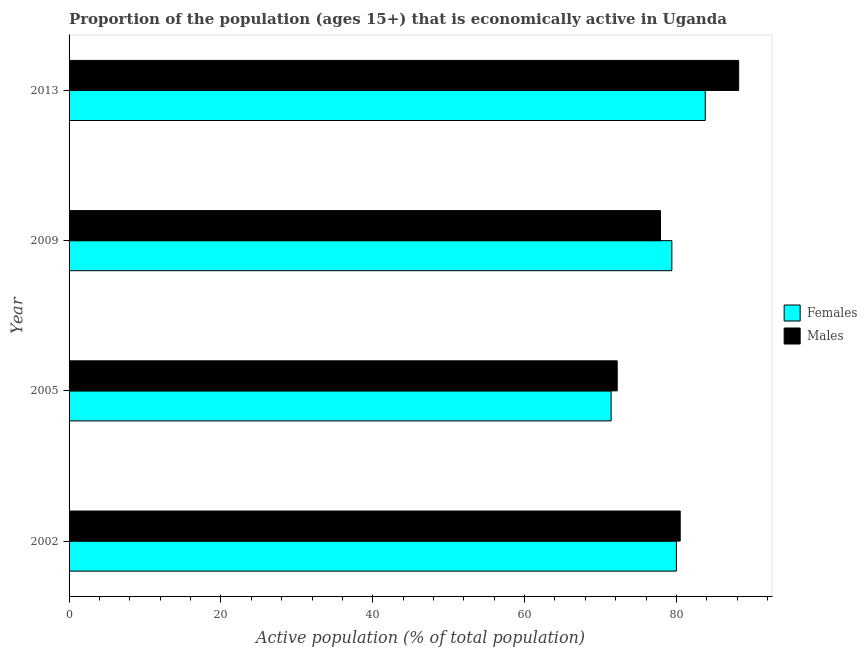How many different coloured bars are there?
Offer a very short reply. 2. Are the number of bars per tick equal to the number of legend labels?
Make the answer very short. Yes. Are the number of bars on each tick of the Y-axis equal?
Your answer should be compact. Yes. How many bars are there on the 4th tick from the top?
Provide a short and direct response. 2. How many bars are there on the 4th tick from the bottom?
Make the answer very short. 2. What is the label of the 4th group of bars from the top?
Keep it short and to the point. 2002. In how many cases, is the number of bars for a given year not equal to the number of legend labels?
Make the answer very short. 0. What is the percentage of economically active male population in 2009?
Offer a terse response. 77.9. Across all years, what is the maximum percentage of economically active male population?
Give a very brief answer. 88.2. Across all years, what is the minimum percentage of economically active male population?
Provide a short and direct response. 72.2. In which year was the percentage of economically active male population maximum?
Ensure brevity in your answer.  2013. In which year was the percentage of economically active male population minimum?
Offer a terse response. 2005. What is the total percentage of economically active male population in the graph?
Provide a short and direct response. 318.8. What is the difference between the percentage of economically active male population in 2009 and the percentage of economically active female population in 2002?
Keep it short and to the point. -2.1. What is the average percentage of economically active male population per year?
Provide a short and direct response. 79.7. What is the ratio of the percentage of economically active female population in 2005 to that in 2013?
Provide a succinct answer. 0.85. What is the difference between the highest and the second highest percentage of economically active female population?
Ensure brevity in your answer.  3.8. What is the difference between the highest and the lowest percentage of economically active female population?
Offer a very short reply. 12.4. What does the 1st bar from the top in 2009 represents?
Offer a very short reply. Males. What does the 1st bar from the bottom in 2009 represents?
Offer a terse response. Females. How many years are there in the graph?
Your response must be concise. 4. Are the values on the major ticks of X-axis written in scientific E-notation?
Keep it short and to the point. No. Where does the legend appear in the graph?
Provide a short and direct response. Center right. How are the legend labels stacked?
Make the answer very short. Vertical. What is the title of the graph?
Your answer should be very brief. Proportion of the population (ages 15+) that is economically active in Uganda. Does "GDP per capita" appear as one of the legend labels in the graph?
Offer a very short reply. No. What is the label or title of the X-axis?
Provide a short and direct response. Active population (% of total population). What is the label or title of the Y-axis?
Keep it short and to the point. Year. What is the Active population (% of total population) of Males in 2002?
Provide a short and direct response. 80.5. What is the Active population (% of total population) in Females in 2005?
Keep it short and to the point. 71.4. What is the Active population (% of total population) of Males in 2005?
Give a very brief answer. 72.2. What is the Active population (% of total population) in Females in 2009?
Ensure brevity in your answer.  79.4. What is the Active population (% of total population) in Males in 2009?
Ensure brevity in your answer.  77.9. What is the Active population (% of total population) of Females in 2013?
Offer a very short reply. 83.8. What is the Active population (% of total population) of Males in 2013?
Ensure brevity in your answer.  88.2. Across all years, what is the maximum Active population (% of total population) in Females?
Your response must be concise. 83.8. Across all years, what is the maximum Active population (% of total population) in Males?
Ensure brevity in your answer.  88.2. Across all years, what is the minimum Active population (% of total population) in Females?
Provide a short and direct response. 71.4. Across all years, what is the minimum Active population (% of total population) in Males?
Ensure brevity in your answer.  72.2. What is the total Active population (% of total population) in Females in the graph?
Your answer should be compact. 314.6. What is the total Active population (% of total population) in Males in the graph?
Provide a succinct answer. 318.8. What is the difference between the Active population (% of total population) of Males in 2002 and that in 2005?
Provide a succinct answer. 8.3. What is the difference between the Active population (% of total population) of Females in 2002 and that in 2009?
Make the answer very short. 0.6. What is the difference between the Active population (% of total population) in Males in 2002 and that in 2009?
Give a very brief answer. 2.6. What is the difference between the Active population (% of total population) in Females in 2002 and that in 2013?
Offer a very short reply. -3.8. What is the difference between the Active population (% of total population) in Males in 2002 and that in 2013?
Provide a succinct answer. -7.7. What is the difference between the Active population (% of total population) of Females in 2005 and that in 2009?
Offer a terse response. -8. What is the difference between the Active population (% of total population) in Females in 2002 and the Active population (% of total population) in Males in 2009?
Make the answer very short. 2.1. What is the difference between the Active population (% of total population) in Females in 2002 and the Active population (% of total population) in Males in 2013?
Your answer should be compact. -8.2. What is the difference between the Active population (% of total population) of Females in 2005 and the Active population (% of total population) of Males in 2009?
Keep it short and to the point. -6.5. What is the difference between the Active population (% of total population) of Females in 2005 and the Active population (% of total population) of Males in 2013?
Make the answer very short. -16.8. What is the difference between the Active population (% of total population) of Females in 2009 and the Active population (% of total population) of Males in 2013?
Your response must be concise. -8.8. What is the average Active population (% of total population) in Females per year?
Give a very brief answer. 78.65. What is the average Active population (% of total population) of Males per year?
Provide a succinct answer. 79.7. What is the ratio of the Active population (% of total population) of Females in 2002 to that in 2005?
Your answer should be compact. 1.12. What is the ratio of the Active population (% of total population) in Males in 2002 to that in 2005?
Provide a short and direct response. 1.11. What is the ratio of the Active population (% of total population) in Females in 2002 to that in 2009?
Give a very brief answer. 1.01. What is the ratio of the Active population (% of total population) in Males in 2002 to that in 2009?
Make the answer very short. 1.03. What is the ratio of the Active population (% of total population) of Females in 2002 to that in 2013?
Offer a very short reply. 0.95. What is the ratio of the Active population (% of total population) in Males in 2002 to that in 2013?
Keep it short and to the point. 0.91. What is the ratio of the Active population (% of total population) in Females in 2005 to that in 2009?
Your response must be concise. 0.9. What is the ratio of the Active population (% of total population) in Males in 2005 to that in 2009?
Offer a terse response. 0.93. What is the ratio of the Active population (% of total population) of Females in 2005 to that in 2013?
Provide a succinct answer. 0.85. What is the ratio of the Active population (% of total population) in Males in 2005 to that in 2013?
Your answer should be compact. 0.82. What is the ratio of the Active population (% of total population) of Females in 2009 to that in 2013?
Your answer should be very brief. 0.95. What is the ratio of the Active population (% of total population) of Males in 2009 to that in 2013?
Make the answer very short. 0.88. What is the difference between the highest and the second highest Active population (% of total population) in Females?
Ensure brevity in your answer.  3.8. 